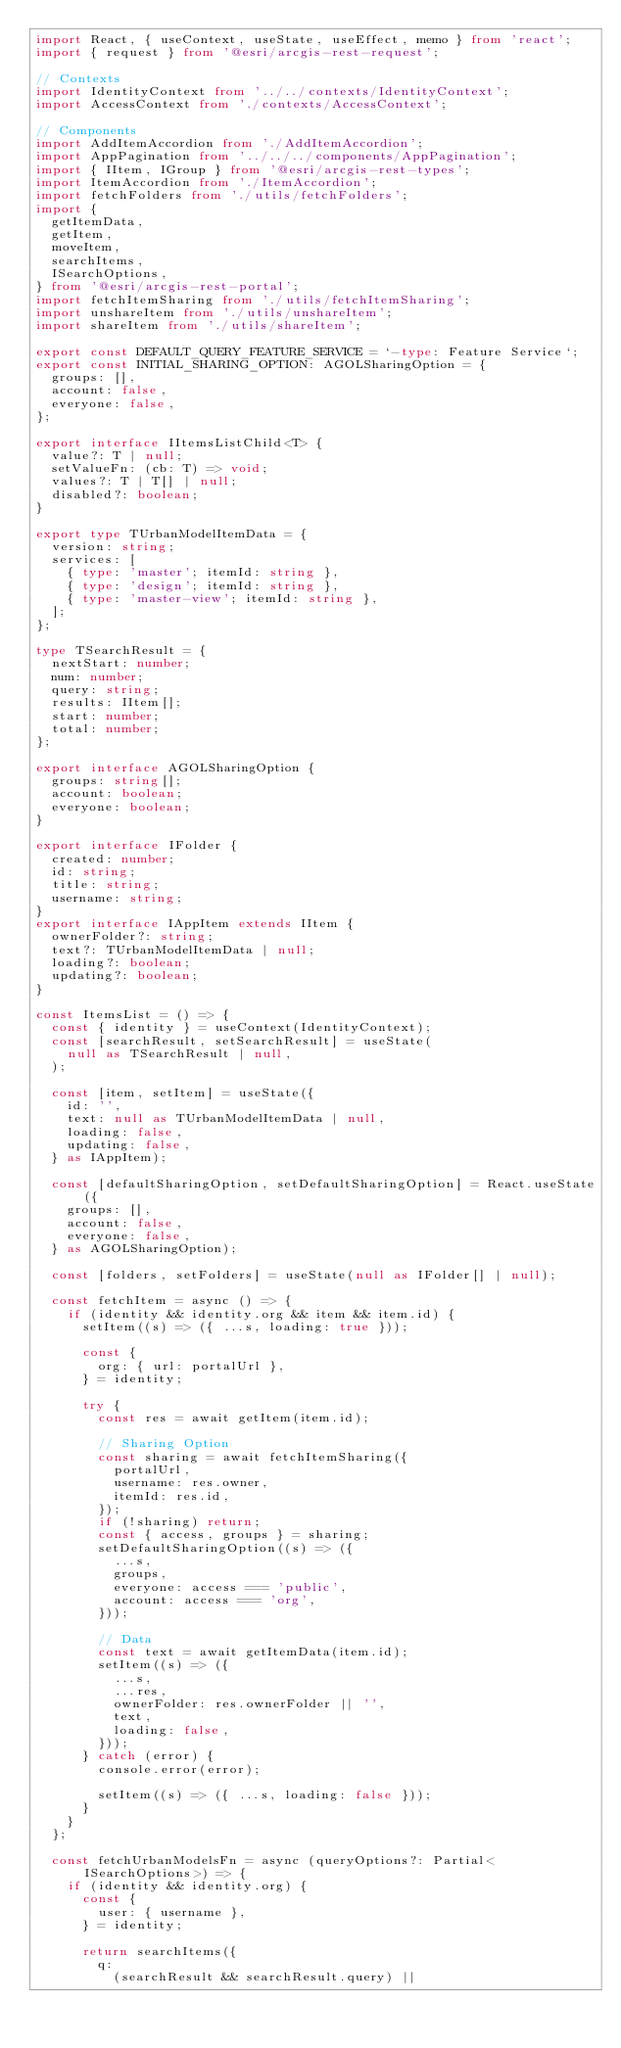Convert code to text. <code><loc_0><loc_0><loc_500><loc_500><_TypeScript_>import React, { useContext, useState, useEffect, memo } from 'react';
import { request } from '@esri/arcgis-rest-request';

// Contexts
import IdentityContext from '../../contexts/IdentityContext';
import AccessContext from './contexts/AccessContext';

// Components
import AddItemAccordion from './AddItemAccordion';
import AppPagination from '../../../components/AppPagination';
import { IItem, IGroup } from '@esri/arcgis-rest-types';
import ItemAccordion from './ItemAccordion';
import fetchFolders from './utils/fetchFolders';
import {
  getItemData,
  getItem,
  moveItem,
  searchItems,
  ISearchOptions,
} from '@esri/arcgis-rest-portal';
import fetchItemSharing from './utils/fetchItemSharing';
import unshareItem from './utils/unshareItem';
import shareItem from './utils/shareItem';

export const DEFAULT_QUERY_FEATURE_SERVICE = `-type: Feature Service`;
export const INITIAL_SHARING_OPTION: AGOLSharingOption = {
  groups: [],
  account: false,
  everyone: false,
};

export interface IItemsListChild<T> {
  value?: T | null;
  setValueFn: (cb: T) => void;
  values?: T | T[] | null;
  disabled?: boolean;
}

export type TUrbanModelItemData = {
  version: string;
  services: [
    { type: 'master'; itemId: string },
    { type: 'design'; itemId: string },
    { type: 'master-view'; itemId: string },
  ];
};

type TSearchResult = {
  nextStart: number;
  num: number;
  query: string;
  results: IItem[];
  start: number;
  total: number;
};

export interface AGOLSharingOption {
  groups: string[];
  account: boolean;
  everyone: boolean;
}

export interface IFolder {
  created: number;
  id: string;
  title: string;
  username: string;
}
export interface IAppItem extends IItem {
  ownerFolder?: string;
  text?: TUrbanModelItemData | null;
  loading?: boolean;
  updating?: boolean;
}

const ItemsList = () => {
  const { identity } = useContext(IdentityContext);
  const [searchResult, setSearchResult] = useState(
    null as TSearchResult | null,
  );

  const [item, setItem] = useState({
    id: '',
    text: null as TUrbanModelItemData | null,
    loading: false,
    updating: false,
  } as IAppItem);

  const [defaultSharingOption, setDefaultSharingOption] = React.useState({
    groups: [],
    account: false,
    everyone: false,
  } as AGOLSharingOption);

  const [folders, setFolders] = useState(null as IFolder[] | null);

  const fetchItem = async () => {
    if (identity && identity.org && item && item.id) {
      setItem((s) => ({ ...s, loading: true }));

      const {
        org: { url: portalUrl },
      } = identity;

      try {
        const res = await getItem(item.id);

        // Sharing Option
        const sharing = await fetchItemSharing({
          portalUrl,
          username: res.owner,
          itemId: res.id,
        });
        if (!sharing) return;
        const { access, groups } = sharing;
        setDefaultSharingOption((s) => ({
          ...s,
          groups,
          everyone: access === 'public',
          account: access === 'org',
        }));

        // Data
        const text = await getItemData(item.id);
        setItem((s) => ({
          ...s,
          ...res,
          ownerFolder: res.ownerFolder || '',
          text,
          loading: false,
        }));
      } catch (error) {
        console.error(error);

        setItem((s) => ({ ...s, loading: false }));
      }
    }
  };

  const fetchUrbanModelsFn = async (queryOptions?: Partial<ISearchOptions>) => {
    if (identity && identity.org) {
      const {
        user: { username },
      } = identity;

      return searchItems({
        q:
          (searchResult && searchResult.query) ||</code> 